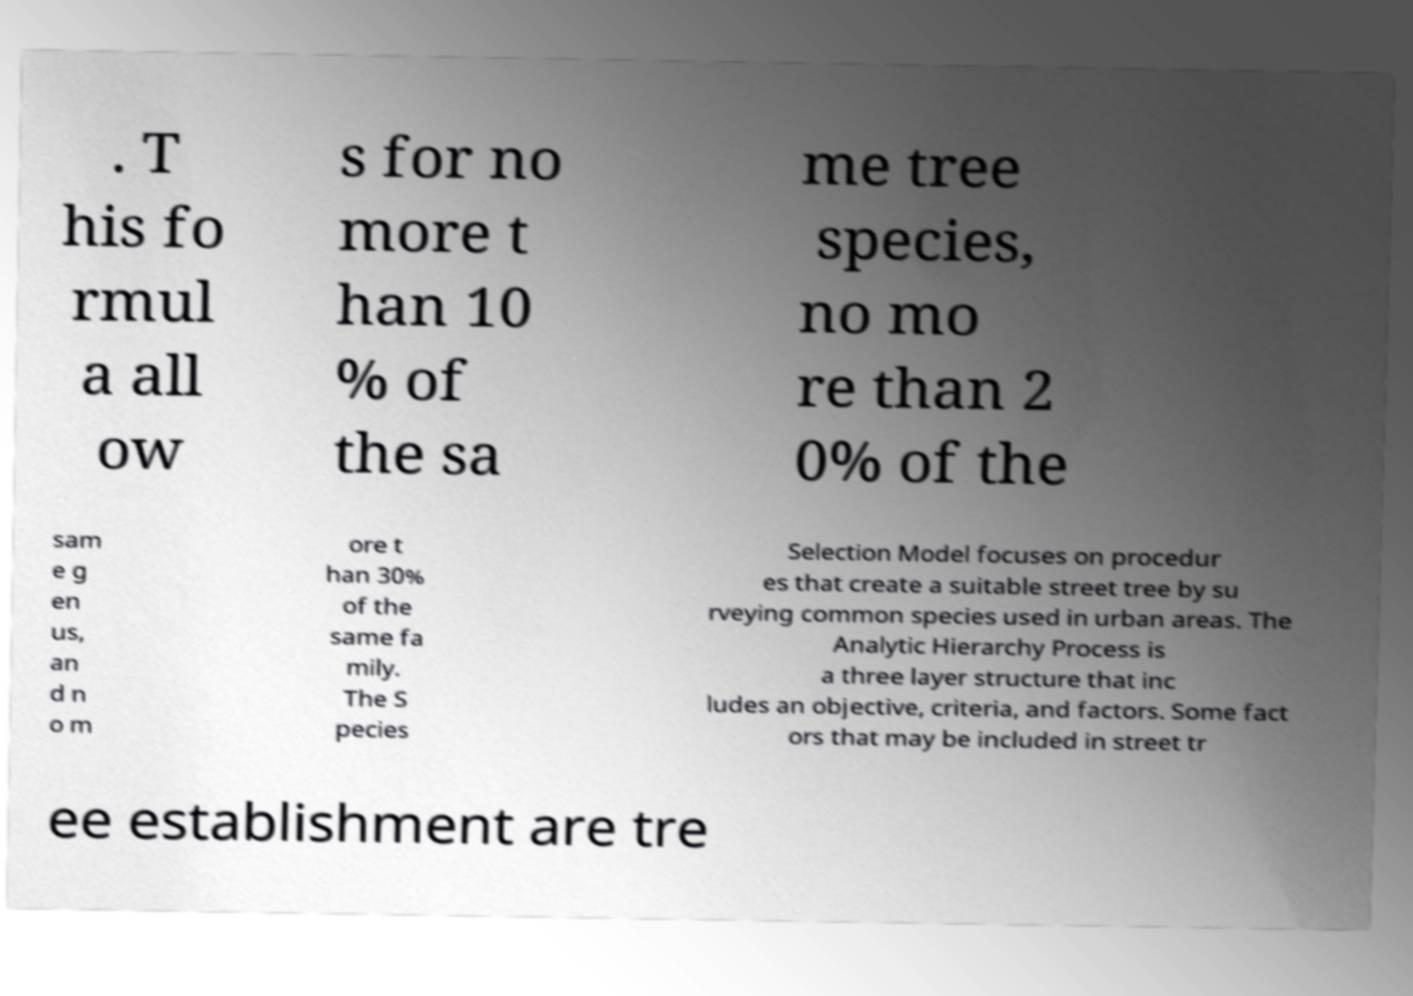There's text embedded in this image that I need extracted. Can you transcribe it verbatim? . T his fo rmul a all ow s for no more t han 10 % of the sa me tree species, no mo re than 2 0% of the sam e g en us, an d n o m ore t han 30% of the same fa mily. The S pecies Selection Model focuses on procedur es that create a suitable street tree by su rveying common species used in urban areas. The Analytic Hierarchy Process is a three layer structure that inc ludes an objective, criteria, and factors. Some fact ors that may be included in street tr ee establishment are tre 